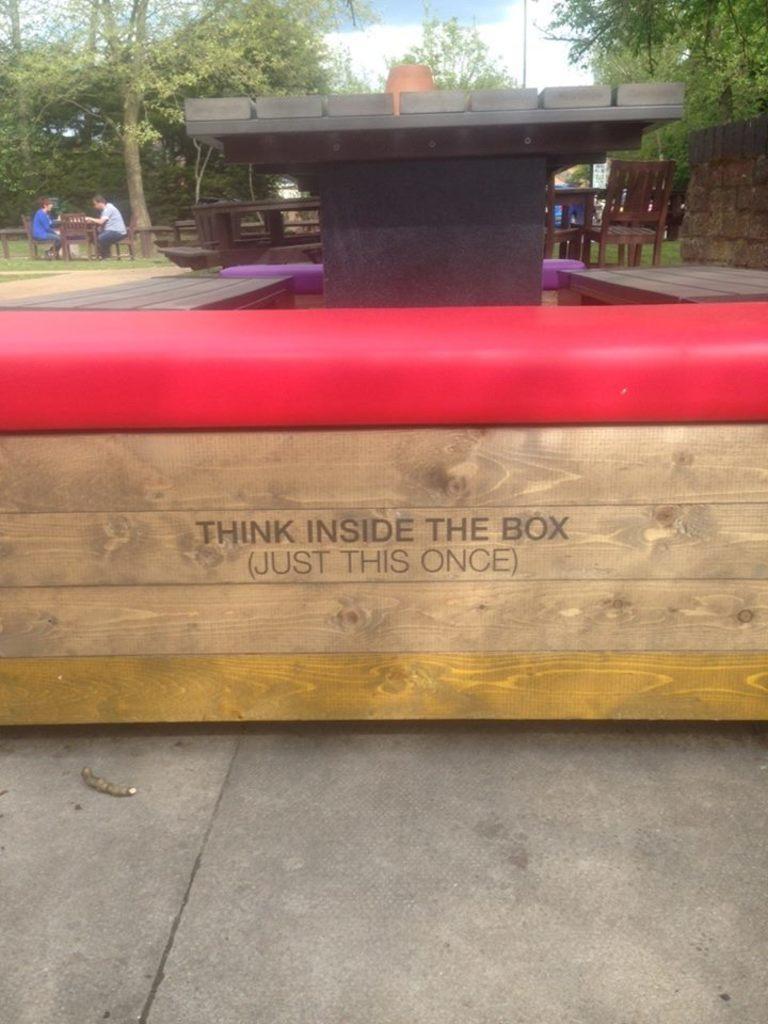How would you summarize this image in a sentence or two? Here in the front we can see a wooden box present on the ground over there and behind it we can see a table on couple of benches present on either side and in the far we can see people sitting over there on chairs and benches and we can see trees and plants present all over there and we can also see clouds in the sky. 